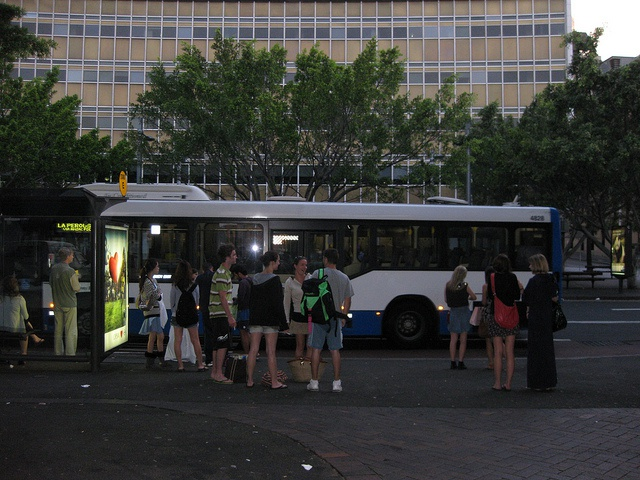Describe the objects in this image and their specific colors. I can see bus in gray and black tones, people in gray and black tones, people in gray, black, and maroon tones, people in gray, black, maroon, and purple tones, and people in gray, black, and darkgreen tones in this image. 